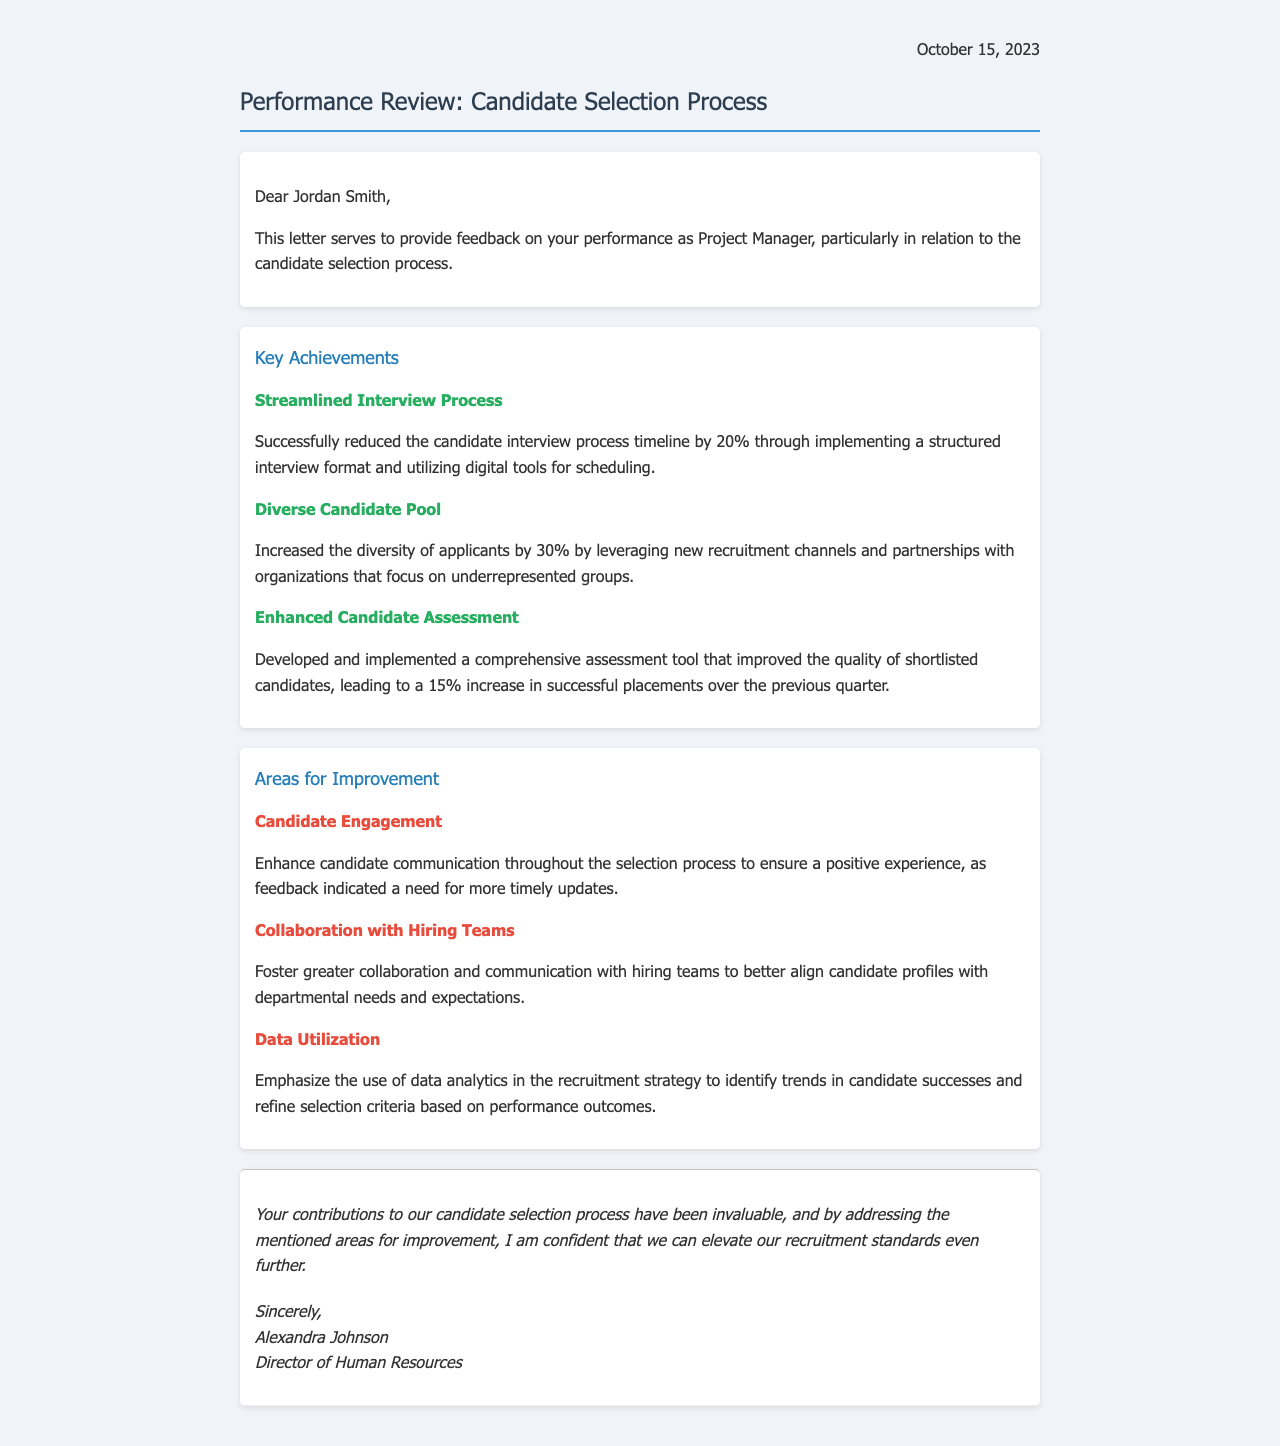What is the date of the performance review letter? The date is mentioned at the beginning of the letter, which is October 15, 2023.
Answer: October 15, 2023 Who is the recipient of the letter? The letter is addressed to Jordan Smith, whose name appears at the start.
Answer: Jordan Smith By what percentage was the candidate interview process timeline reduced? The letter states a 20% reduction in the interview timeline as a key achievement.
Answer: 20% What was the increase in the diversity of applicants? The document highlights a 30% increase in the diversity of applicants as a key achievement.
Answer: 30% What area for improvement relates to candidate communication? The document mentions "Candidate Engagement" as an area for improvement specifically addressing candidate communication.
Answer: Candidate Engagement What is suggested to enhance collaboration with hiring teams? The letter discusses fostering "greater collaboration and communication" with hiring teams.
Answer: Greater collaboration What kind of tool was developed to improve candidate assessment? The document refers to a "comprehensive assessment tool" designed for better evaluation of candidates.
Answer: Comprehensive assessment tool Who authored the performance review letter? The signature at the end of the letter indicates the author is Alexandra Johnson.
Answer: Alexandra Johnson 